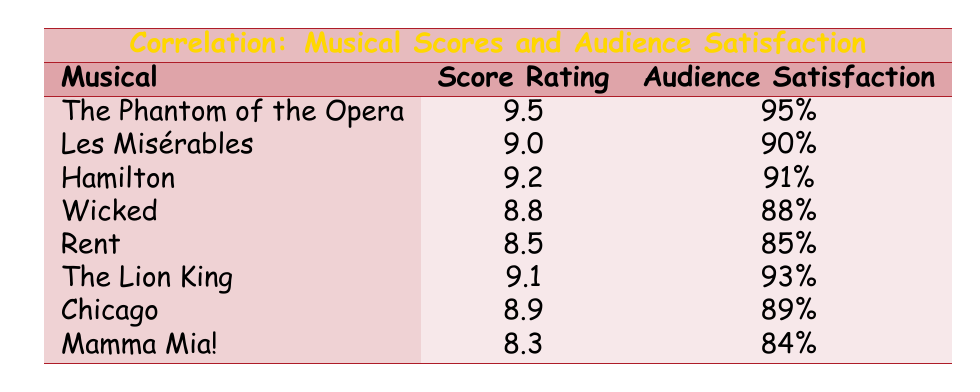What is the musical score rating for "The Phantom of the Opera"? The musical score rating for "The Phantom of the Opera" is given directly in the table.
Answer: 9.5 Which musical has the highest audience satisfaction rating? Looking at the audience satisfaction ratings listed in the table, "The Phantom of the Opera" has the highest rating of 95%.
Answer: The Phantom of the Opera What is the average musical score rating across all the listed musicals? To find the average, we add all the score ratings: (9.5 + 9.0 + 9.2 + 8.8 + 8.5 + 9.1 + 8.9 + 8.3) = 71.3. There are 8 musicals, so the average score is 71.3 / 8 = 8.9125.
Answer: 8.91 Did "Rent" have a higher audience satisfaction rating than "Mamma Mia!"? Comparing the audience satisfaction ratings in the table, "Rent" has a rating of 85% and "Mamma Mia!" has a rating of 84%. Since 85% is greater than 84%, the statement is true.
Answer: Yes If you were to increase "Chicago's" score rating by 1 point, what would its new score rating be? "Chicago" currently has a score rating of 8.9. Increasing this by 1 point would result in a new rating of 8.9 + 1 = 9.9.
Answer: 9.9 What is the difference in audience satisfaction ratings between "Les Misérables" and "Wicked"? "Les Misérables" has an audience satisfaction rating of 90%, while "Wicked" is at 88%. The difference is 90% - 88% = 2%.
Answer: 2% Is the average audience satisfaction rating for musicals with a score rating above 9.0 higher than 90%? The musicals with a score rating above 9.0 are "The Phantom of the Opera", "Les Misérables", "Hamilton", and "The Lion King". Their audience satisfaction ratings are 95%, 90%, 91%, and 93% respectively. The average is (95 + 90 + 91 + 93) / 4 = 92.25%, which is greater than 90%.
Answer: Yes What is the total score rating of all the musicals listed in the table? To get the total score rating, we add all the individual score ratings: 9.5 + 9.0 + 9.2 + 8.8 + 8.5 + 9.1 + 8.9 + 8.3 = 71.3.
Answer: 71.3 